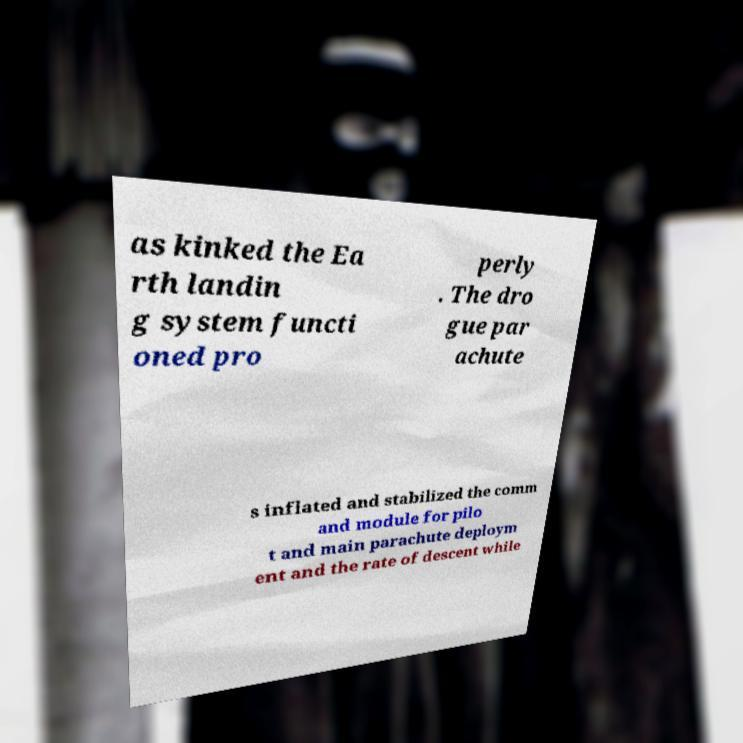I need the written content from this picture converted into text. Can you do that? as kinked the Ea rth landin g system functi oned pro perly . The dro gue par achute s inflated and stabilized the comm and module for pilo t and main parachute deploym ent and the rate of descent while 